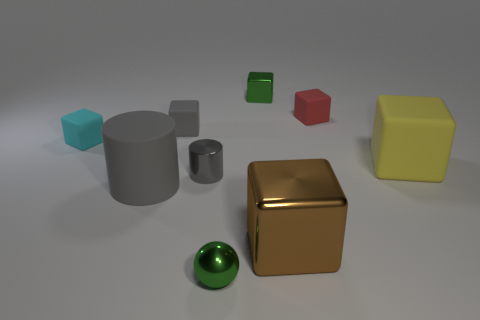Are there more small green objects that are in front of the cyan object than green shiny balls on the left side of the gray matte cylinder?
Make the answer very short. Yes. What size is the green metallic block?
Your answer should be very brief. Small. Is the color of the big rubber object to the left of the small sphere the same as the tiny metallic cylinder?
Provide a succinct answer. Yes. Is there any other thing that has the same shape as the small cyan rubber thing?
Keep it short and to the point. Yes. Are there any small cubes that are on the right side of the big brown cube behind the tiny metal sphere?
Keep it short and to the point. Yes. Is the number of gray things behind the tiny green metal block less than the number of gray metal objects that are behind the cyan matte thing?
Your response must be concise. No. There is a cyan cube that is on the left side of the small green thing in front of the cyan cube to the left of the gray metal thing; what size is it?
Provide a succinct answer. Small. There is a gray matte object behind the gray shiny cylinder; is it the same size as the large gray matte cylinder?
Give a very brief answer. No. How many other things are the same material as the small gray cylinder?
Ensure brevity in your answer.  3. Are there more big purple metallic cylinders than large yellow blocks?
Keep it short and to the point. No. 